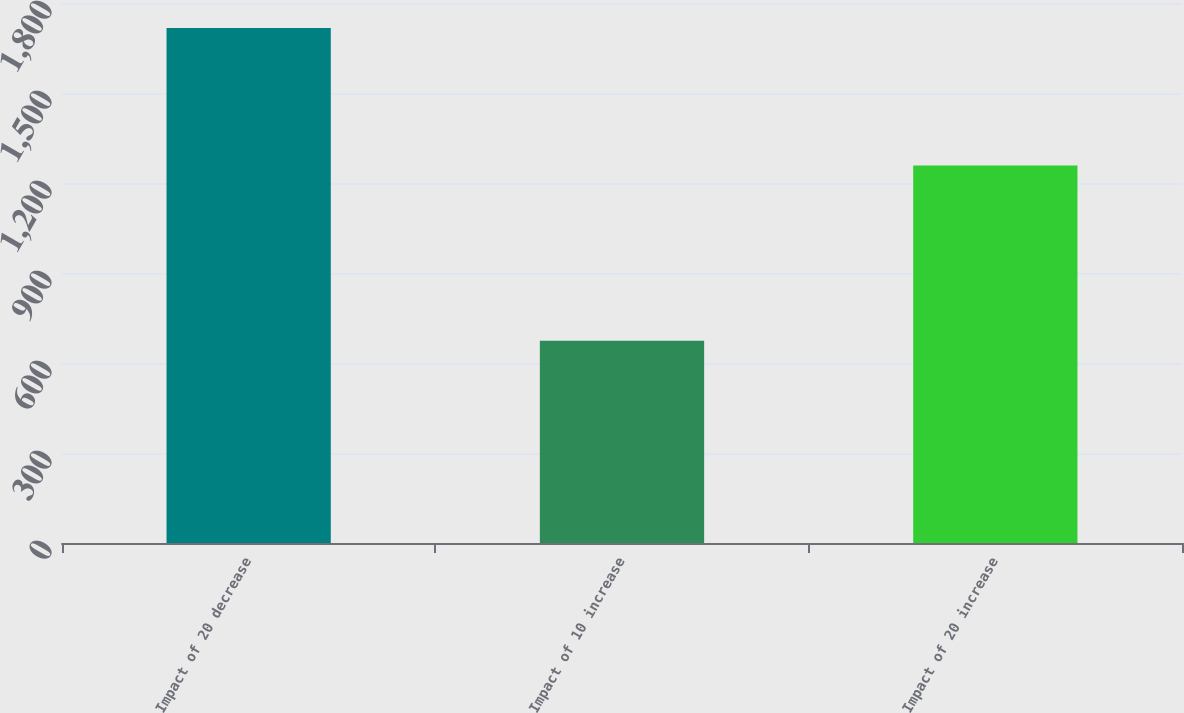<chart> <loc_0><loc_0><loc_500><loc_500><bar_chart><fcel>Impact of 20 decrease<fcel>Impact of 10 increase<fcel>Impact of 20 increase<nl><fcel>1717<fcel>674<fcel>1258<nl></chart> 